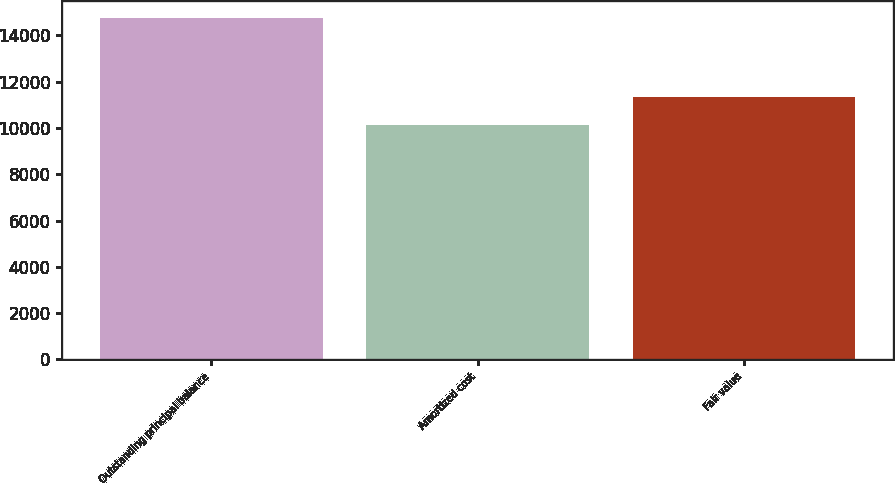Convert chart to OTSL. <chart><loc_0><loc_0><loc_500><loc_500><bar_chart><fcel>Outstanding principal balance<fcel>Amortized cost<fcel>Fair value<nl><fcel>14741<fcel>10110<fcel>11338<nl></chart> 